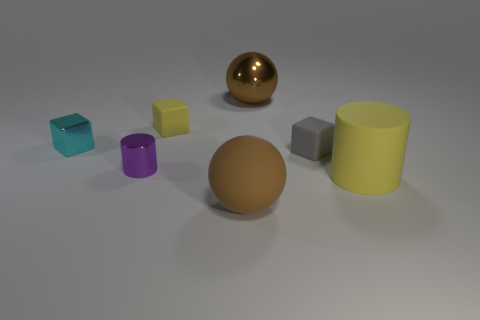Subtract all tiny rubber cubes. How many cubes are left? 1 Subtract all red cubes. Subtract all gray balls. How many cubes are left? 3 Add 2 tiny matte cubes. How many objects exist? 9 Subtract all cylinders. How many objects are left? 5 Subtract 0 cyan spheres. How many objects are left? 7 Subtract all big red rubber things. Subtract all gray matte blocks. How many objects are left? 6 Add 3 big things. How many big things are left? 6 Add 5 cyan blocks. How many cyan blocks exist? 6 